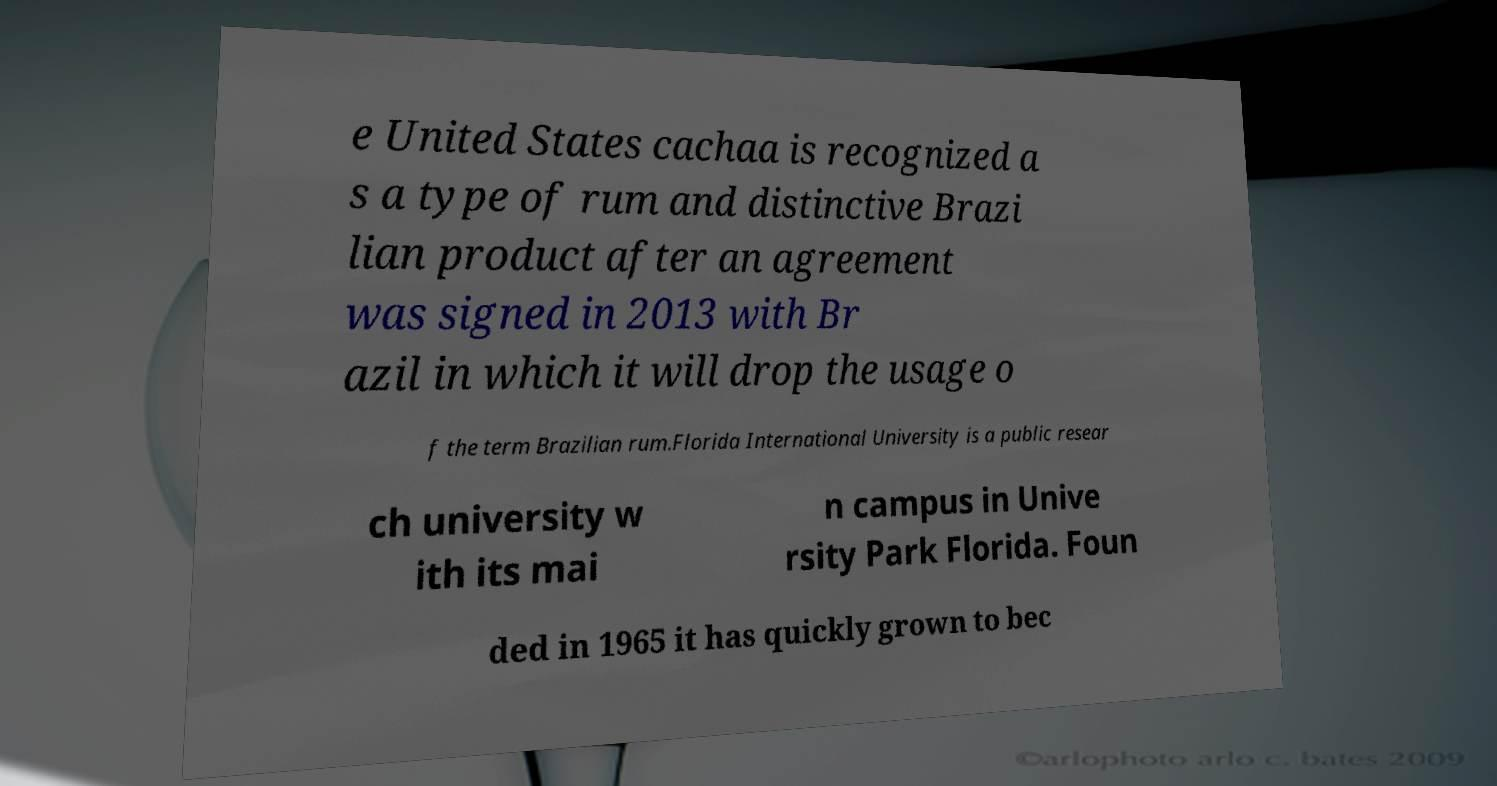Could you assist in decoding the text presented in this image and type it out clearly? e United States cachaa is recognized a s a type of rum and distinctive Brazi lian product after an agreement was signed in 2013 with Br azil in which it will drop the usage o f the term Brazilian rum.Florida International University is a public resear ch university w ith its mai n campus in Unive rsity Park Florida. Foun ded in 1965 it has quickly grown to bec 